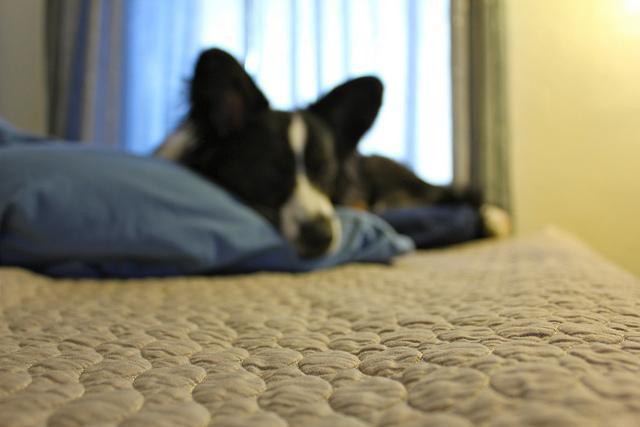How many men are wearing a striped shirt?
Give a very brief answer. 0. 